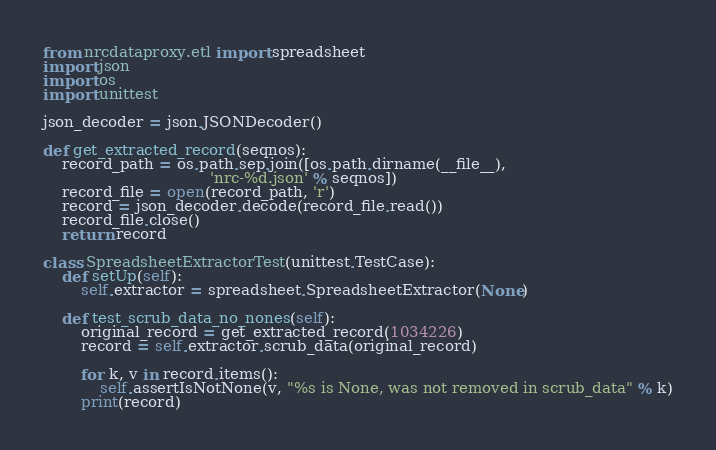Convert code to text. <code><loc_0><loc_0><loc_500><loc_500><_Python_>from nrcdataproxy.etl import spreadsheet
import json
import os
import unittest

json_decoder = json.JSONDecoder()

def get_extracted_record(seqnos):
    record_path = os.path.sep.join([os.path.dirname(__file__),
                                   'nrc-%d.json' % seqnos])
    record_file = open(record_path, 'r')
    record = json_decoder.decode(record_file.read())
    record_file.close()
    return record

class SpreadsheetExtractorTest(unittest.TestCase):
    def setUp(self):
        self.extractor = spreadsheet.SpreadsheetExtractor(None)

    def test_scrub_data_no_nones(self):
        original_record = get_extracted_record(1034226)
        record = self.extractor.scrub_data(original_record)
        
        for k, v in record.items():
            self.assertIsNotNone(v, "%s is None, was not removed in scrub_data" % k)
        print(record)
</code> 